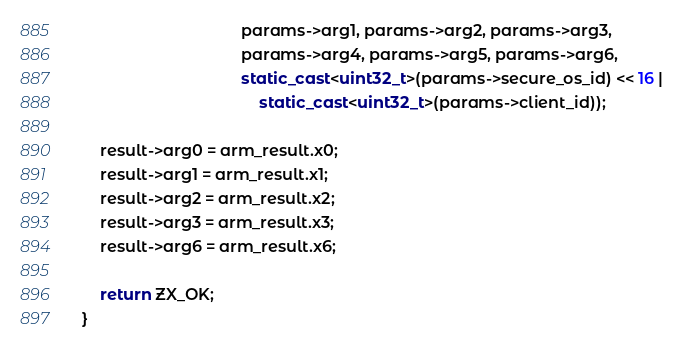Convert code to text. <code><loc_0><loc_0><loc_500><loc_500><_C++_>                                    params->arg1, params->arg2, params->arg3,
                                    params->arg4, params->arg5, params->arg6,
                                    static_cast<uint32_t>(params->secure_os_id) << 16 |
                                        static_cast<uint32_t>(params->client_id));

    result->arg0 = arm_result.x0;
    result->arg1 = arm_result.x1;
    result->arg2 = arm_result.x2;
    result->arg3 = arm_result.x3;
    result->arg6 = arm_result.x6;

    return ZX_OK;
}
</code> 